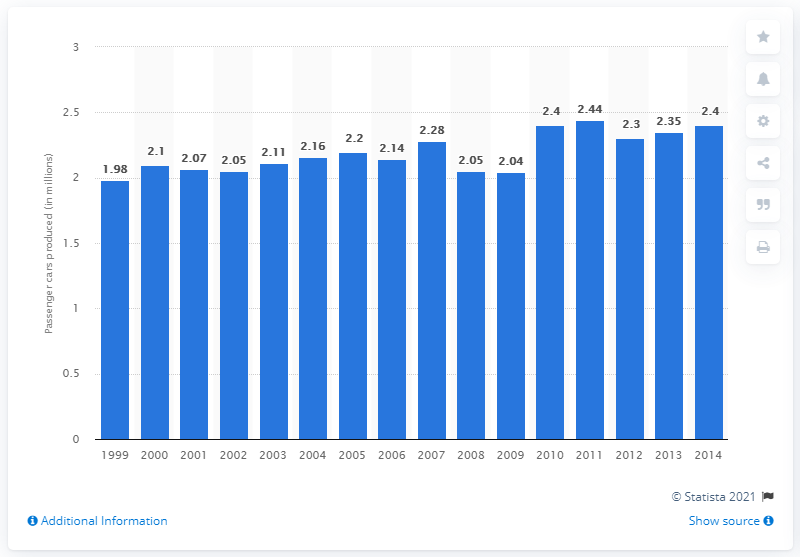Indicate a few pertinent items in this graphic. In 2013, Renault produced 2,350,000 passenger vehicles worldwide. 